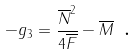Convert formula to latex. <formula><loc_0><loc_0><loc_500><loc_500>- g _ { 3 } = \frac { \overline { N } ^ { 2 } } { 4 \overline { F } } - \overline { M } \text { .}</formula> 